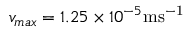Convert formula to latex. <formula><loc_0><loc_0><loc_500><loc_500>v _ { \max } = 1 . 2 5 \times 1 0 ^ { - 5 } m s ^ { - 1 }</formula> 